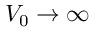Convert formula to latex. <formula><loc_0><loc_0><loc_500><loc_500>V _ { 0 } \to \infty</formula> 